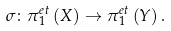<formula> <loc_0><loc_0><loc_500><loc_500>\sigma \colon \pi _ { 1 } ^ { e t } \left ( X \right ) \rightarrow \pi _ { 1 } ^ { e t } \left ( Y \right ) .</formula> 